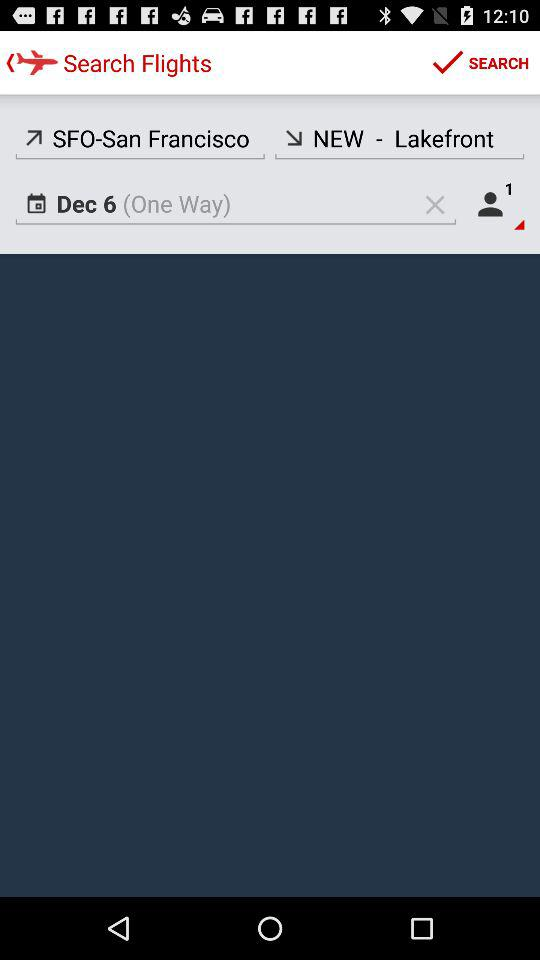What type of trip is the person looking for? The person is looking for a one-way trip. 